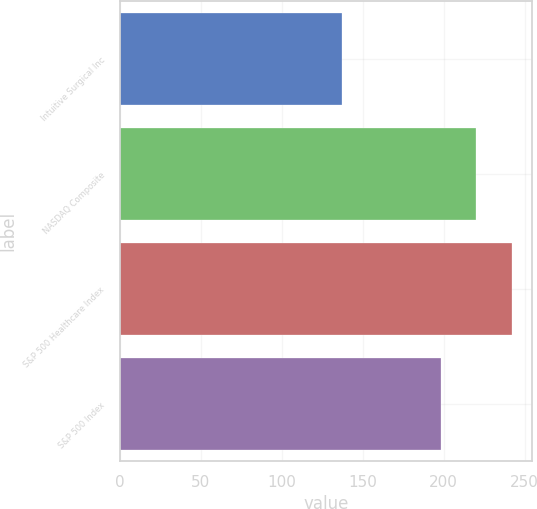<chart> <loc_0><loc_0><loc_500><loc_500><bar_chart><fcel>Intuitive Surgical Inc<fcel>NASDAQ Composite<fcel>S&P 500 Healthcare Index<fcel>S&P 500 Index<nl><fcel>136.97<fcel>219.89<fcel>242.43<fcel>198.18<nl></chart> 